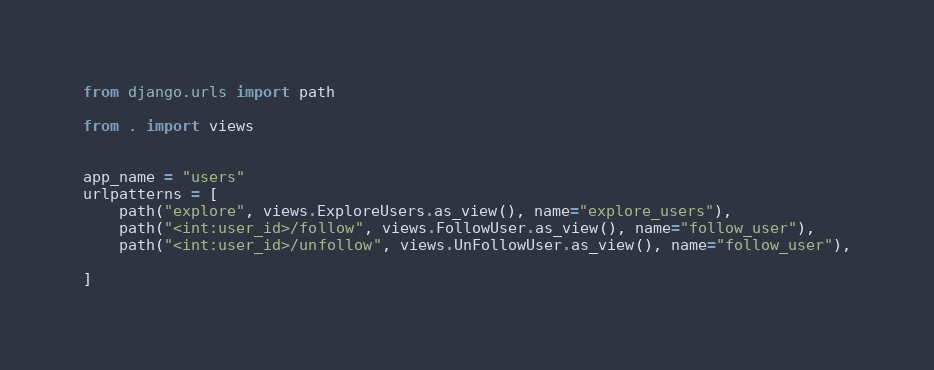Convert code to text. <code><loc_0><loc_0><loc_500><loc_500><_Python_>from django.urls import path

from . import views


app_name = "users"
urlpatterns = [
    path("explore", views.ExploreUsers.as_view(), name="explore_users"),
    path("<int:user_id>/follow", views.FollowUser.as_view(), name="follow_user"),
    path("<int:user_id>/unfollow", views.UnFollowUser.as_view(), name="follow_user"),

]
</code> 